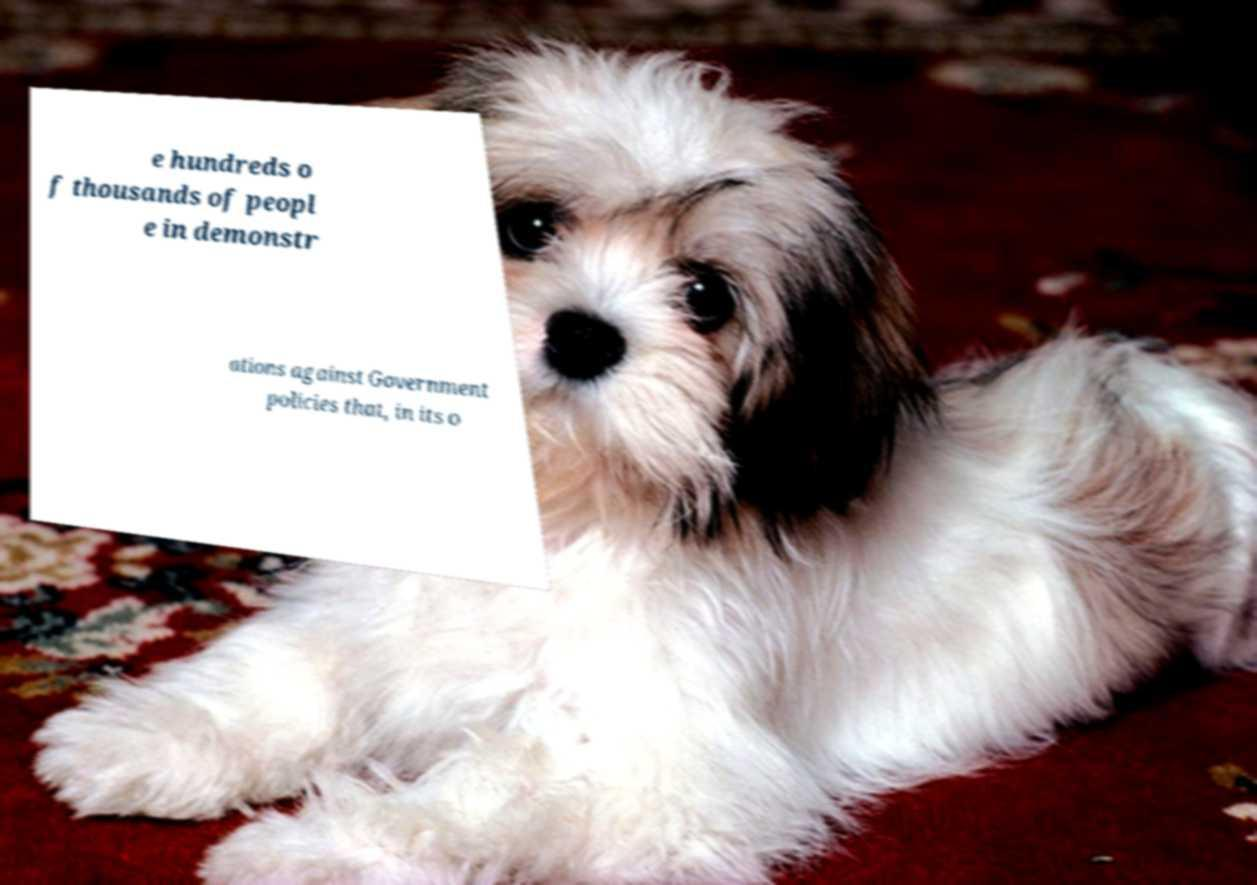Could you assist in decoding the text presented in this image and type it out clearly? e hundreds o f thousands of peopl e in demonstr ations against Government policies that, in its o 